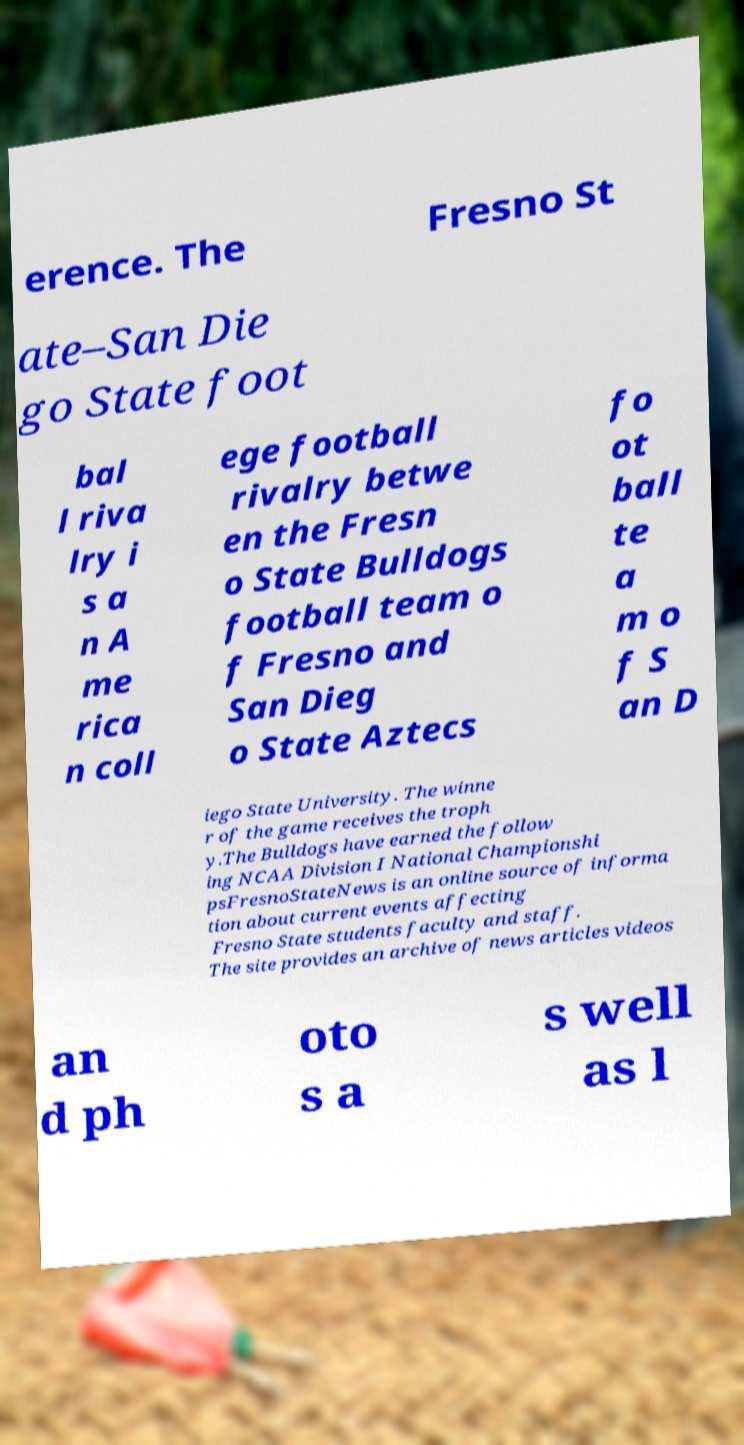I need the written content from this picture converted into text. Can you do that? erence. The Fresno St ate–San Die go State foot bal l riva lry i s a n A me rica n coll ege football rivalry betwe en the Fresn o State Bulldogs football team o f Fresno and San Dieg o State Aztecs fo ot ball te a m o f S an D iego State University. The winne r of the game receives the troph y.The Bulldogs have earned the follow ing NCAA Division I National Championshi psFresnoStateNews is an online source of informa tion about current events affecting Fresno State students faculty and staff. The site provides an archive of news articles videos an d ph oto s a s well as l 